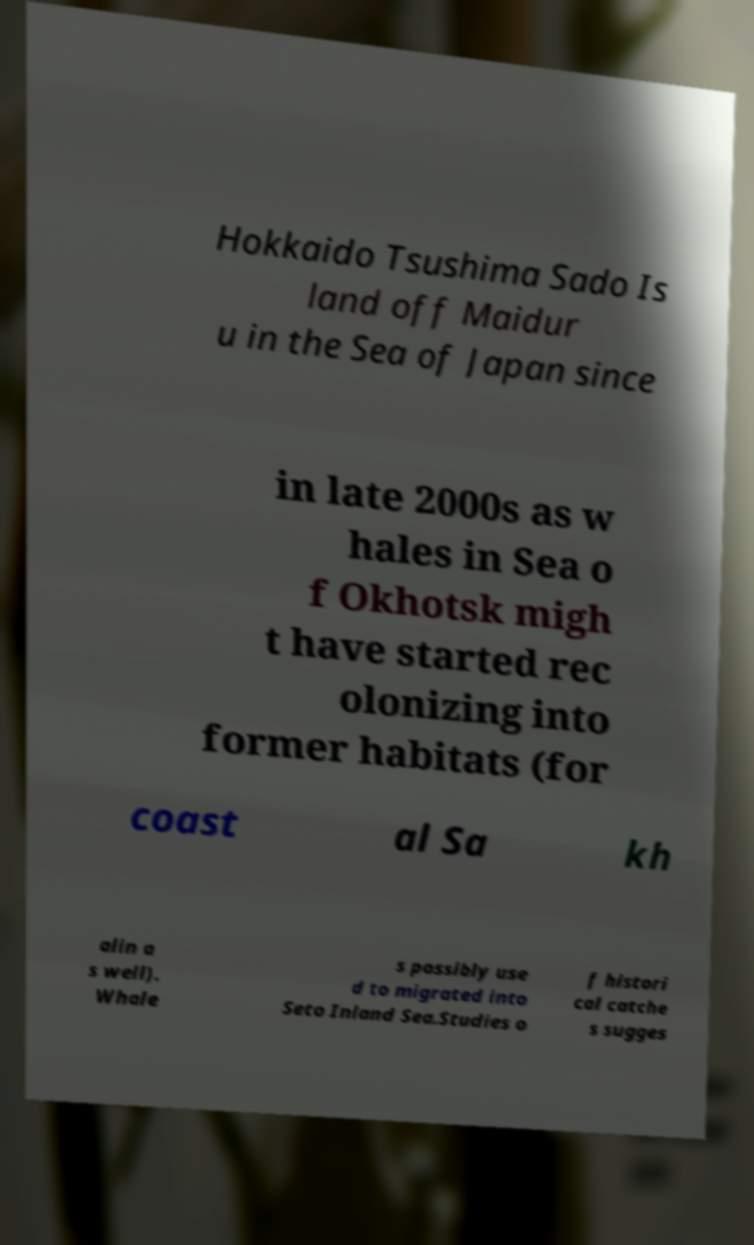Can you read and provide the text displayed in the image?This photo seems to have some interesting text. Can you extract and type it out for me? Hokkaido Tsushima Sado Is land off Maidur u in the Sea of Japan since in late 2000s as w hales in Sea o f Okhotsk migh t have started rec olonizing into former habitats (for coast al Sa kh alin a s well). Whale s possibly use d to migrated into Seto Inland Sea.Studies o f histori cal catche s sugges 